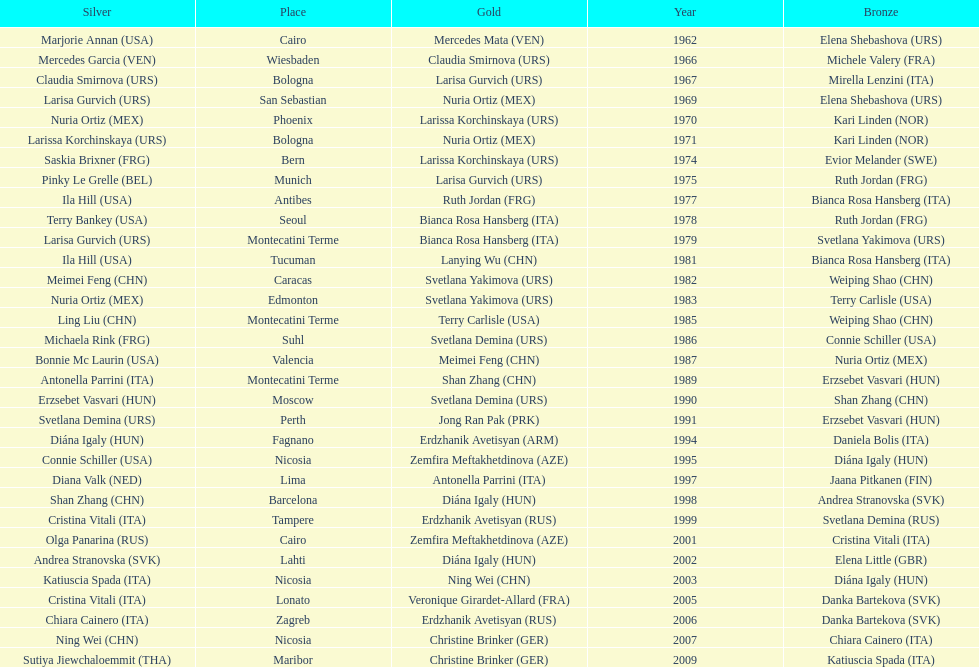Which country has won more gold medals: china or mexico? China. 